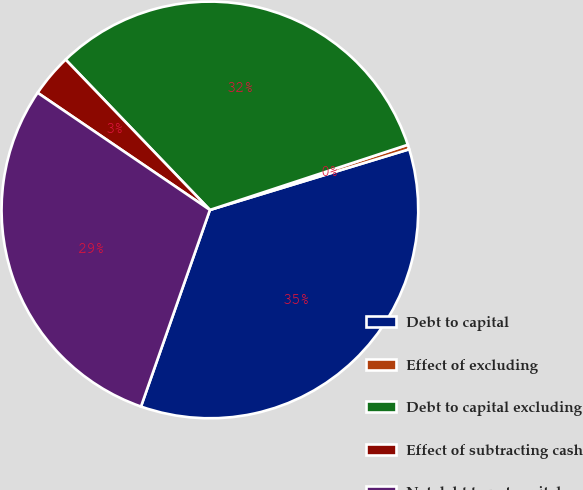Convert chart to OTSL. <chart><loc_0><loc_0><loc_500><loc_500><pie_chart><fcel>Debt to capital<fcel>Effect of excluding<fcel>Debt to capital excluding<fcel>Effect of subtracting cash<fcel>Net debt to net capital<nl><fcel>35.07%<fcel>0.36%<fcel>32.11%<fcel>3.32%<fcel>29.14%<nl></chart> 